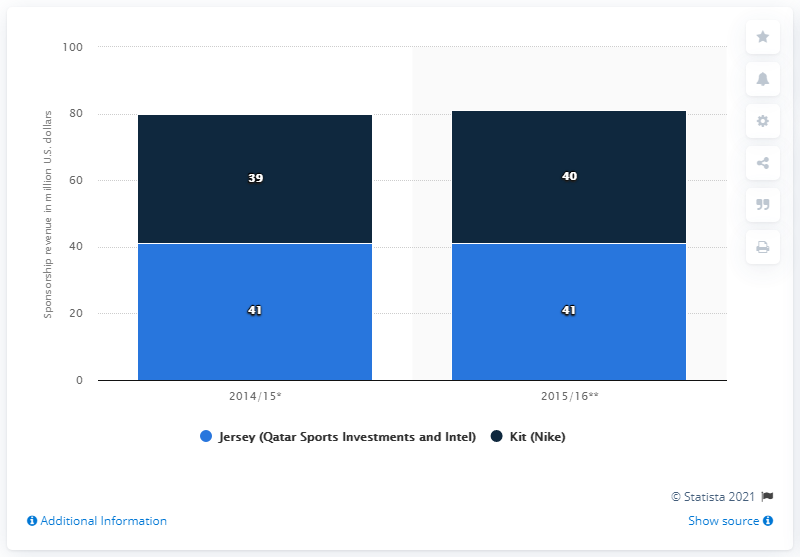Highlight a few significant elements in this photo. In the 2014/15 season, the kit sponsorship revenue for FC Barcelona was 39 million. 